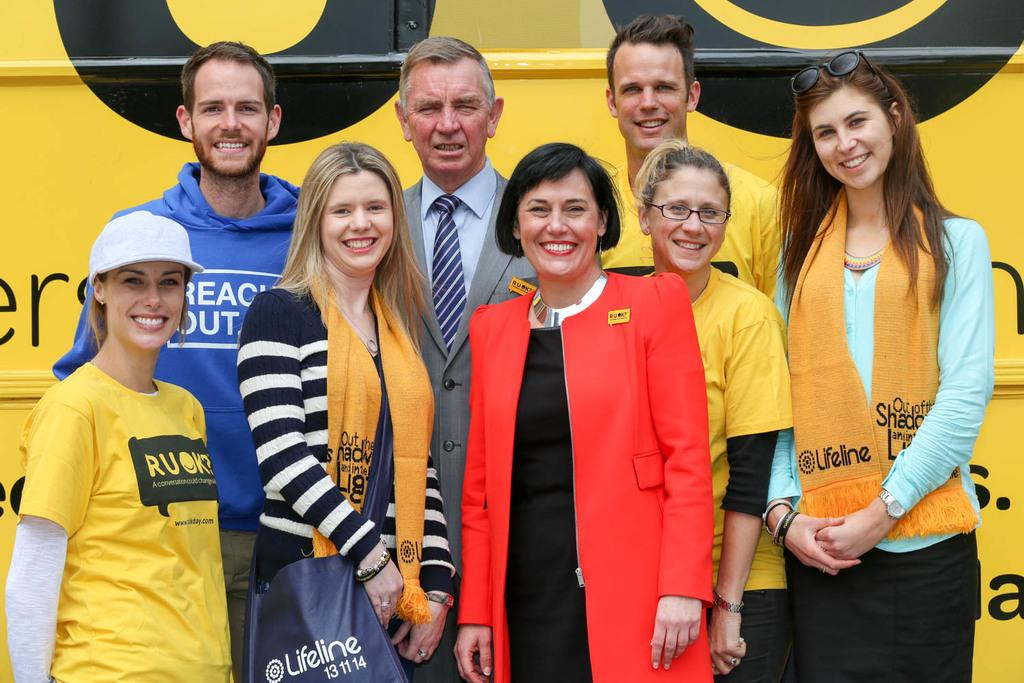<image>
Offer a succinct explanation of the picture presented. The girl on the right wears a scarf by lifeline, 